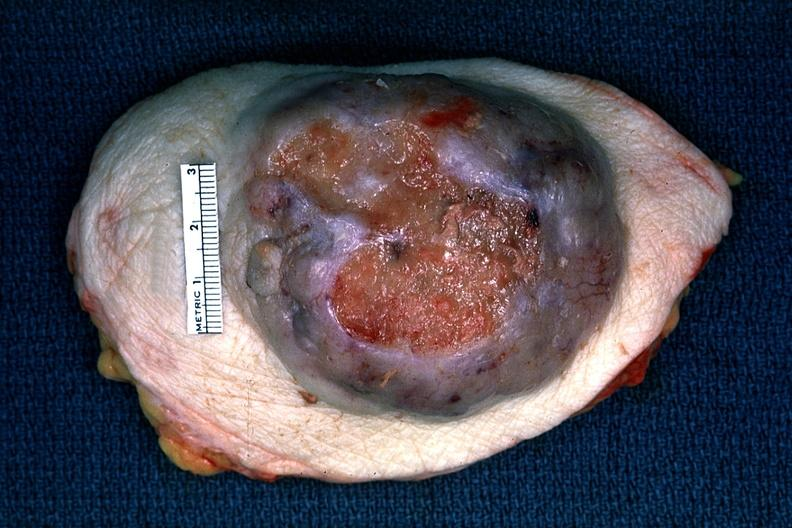s breast present?
Answer the question using a single word or phrase. Yes 